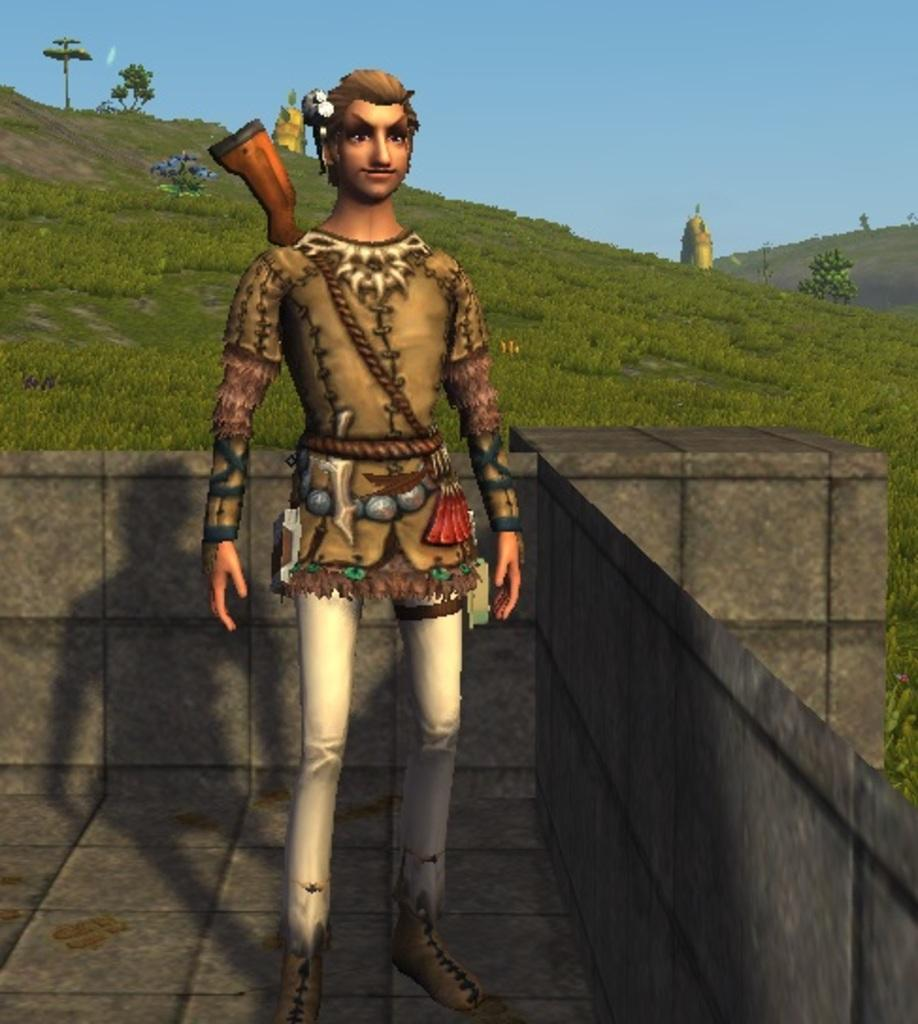What type of image is this, considering the provided fact? The image is animated. What is the main subject in the middle of the image? There is a man in the middle of the image. What type of natural environment is visible in the image? The image contains grass. What is visible at the top of the image? The sky is visible at the top of the image. Where is the playground located in the image? There is no playground present in the image. What type of stew is being prepared in the image? There is no stew preparation visible in the image. Can you describe the man's hairstyle in the image? The provided facts do not mention the man's hairstyle, so it cannot be described. 